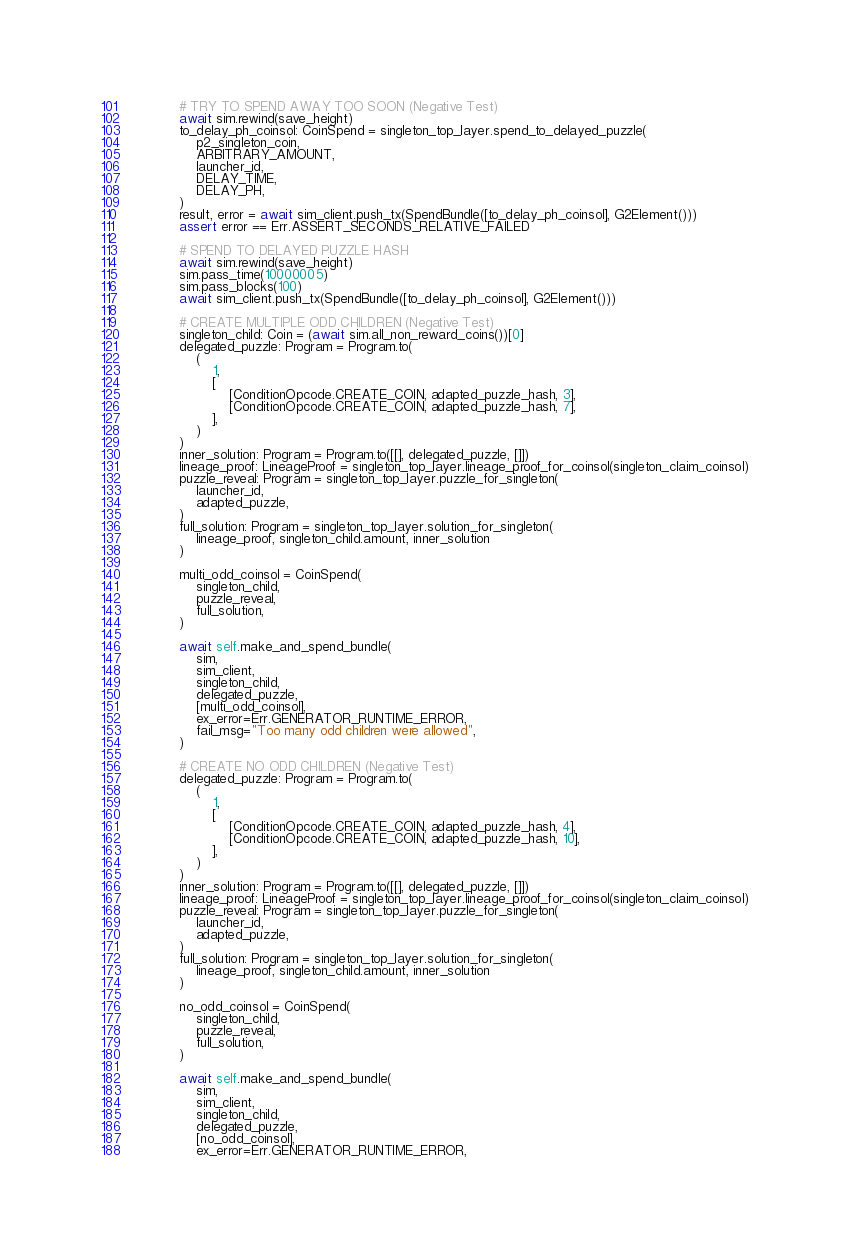Convert code to text. <code><loc_0><loc_0><loc_500><loc_500><_Python_>
            # TRY TO SPEND AWAY TOO SOON (Negative Test)
            await sim.rewind(save_height)
            to_delay_ph_coinsol: CoinSpend = singleton_top_layer.spend_to_delayed_puzzle(
                p2_singleton_coin,
                ARBITRARY_AMOUNT,
                launcher_id,
                DELAY_TIME,
                DELAY_PH,
            )
            result, error = await sim_client.push_tx(SpendBundle([to_delay_ph_coinsol], G2Element()))
            assert error == Err.ASSERT_SECONDS_RELATIVE_FAILED

            # SPEND TO DELAYED PUZZLE HASH
            await sim.rewind(save_height)
            sim.pass_time(10000005)
            sim.pass_blocks(100)
            await sim_client.push_tx(SpendBundle([to_delay_ph_coinsol], G2Element()))

            # CREATE MULTIPLE ODD CHILDREN (Negative Test)
            singleton_child: Coin = (await sim.all_non_reward_coins())[0]
            delegated_puzzle: Program = Program.to(
                (
                    1,
                    [
                        [ConditionOpcode.CREATE_COIN, adapted_puzzle_hash, 3],
                        [ConditionOpcode.CREATE_COIN, adapted_puzzle_hash, 7],
                    ],
                )
            )
            inner_solution: Program = Program.to([[], delegated_puzzle, []])
            lineage_proof: LineageProof = singleton_top_layer.lineage_proof_for_coinsol(singleton_claim_coinsol)
            puzzle_reveal: Program = singleton_top_layer.puzzle_for_singleton(
                launcher_id,
                adapted_puzzle,
            )
            full_solution: Program = singleton_top_layer.solution_for_singleton(
                lineage_proof, singleton_child.amount, inner_solution
            )

            multi_odd_coinsol = CoinSpend(
                singleton_child,
                puzzle_reveal,
                full_solution,
            )

            await self.make_and_spend_bundle(
                sim,
                sim_client,
                singleton_child,
                delegated_puzzle,
                [multi_odd_coinsol],
                ex_error=Err.GENERATOR_RUNTIME_ERROR,
                fail_msg="Too many odd children were allowed",
            )

            # CREATE NO ODD CHILDREN (Negative Test)
            delegated_puzzle: Program = Program.to(
                (
                    1,
                    [
                        [ConditionOpcode.CREATE_COIN, adapted_puzzle_hash, 4],
                        [ConditionOpcode.CREATE_COIN, adapted_puzzle_hash, 10],
                    ],
                )
            )
            inner_solution: Program = Program.to([[], delegated_puzzle, []])
            lineage_proof: LineageProof = singleton_top_layer.lineage_proof_for_coinsol(singleton_claim_coinsol)
            puzzle_reveal: Program = singleton_top_layer.puzzle_for_singleton(
                launcher_id,
                adapted_puzzle,
            )
            full_solution: Program = singleton_top_layer.solution_for_singleton(
                lineage_proof, singleton_child.amount, inner_solution
            )

            no_odd_coinsol = CoinSpend(
                singleton_child,
                puzzle_reveal,
                full_solution,
            )

            await self.make_and_spend_bundle(
                sim,
                sim_client,
                singleton_child,
                delegated_puzzle,
                [no_odd_coinsol],
                ex_error=Err.GENERATOR_RUNTIME_ERROR,</code> 